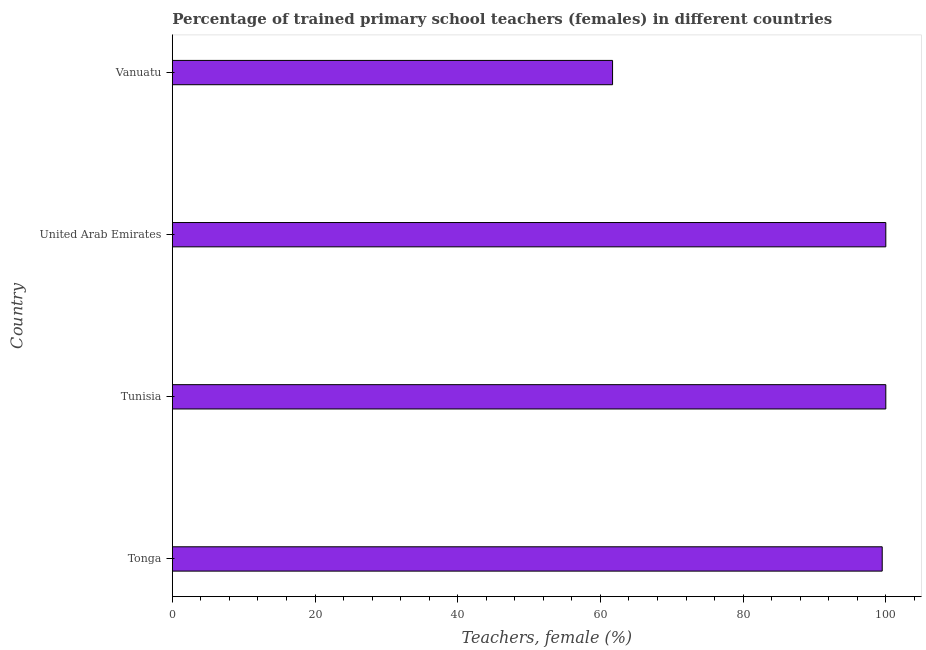Does the graph contain any zero values?
Keep it short and to the point. No. Does the graph contain grids?
Your answer should be very brief. No. What is the title of the graph?
Provide a short and direct response. Percentage of trained primary school teachers (females) in different countries. What is the label or title of the X-axis?
Offer a terse response. Teachers, female (%). What is the label or title of the Y-axis?
Your response must be concise. Country. Across all countries, what is the minimum percentage of trained female teachers?
Keep it short and to the point. 61.7. In which country was the percentage of trained female teachers maximum?
Give a very brief answer. Tunisia. In which country was the percentage of trained female teachers minimum?
Your answer should be compact. Vanuatu. What is the sum of the percentage of trained female teachers?
Ensure brevity in your answer.  361.19. What is the difference between the percentage of trained female teachers in Tonga and Vanuatu?
Provide a short and direct response. 37.8. What is the average percentage of trained female teachers per country?
Your answer should be compact. 90.3. What is the median percentage of trained female teachers?
Your answer should be very brief. 99.75. What is the ratio of the percentage of trained female teachers in Tunisia to that in Vanuatu?
Your response must be concise. 1.62. What is the difference between the highest and the second highest percentage of trained female teachers?
Your response must be concise. 0. Is the sum of the percentage of trained female teachers in Tunisia and United Arab Emirates greater than the maximum percentage of trained female teachers across all countries?
Provide a succinct answer. Yes. What is the difference between the highest and the lowest percentage of trained female teachers?
Make the answer very short. 38.3. What is the difference between two consecutive major ticks on the X-axis?
Ensure brevity in your answer.  20. Are the values on the major ticks of X-axis written in scientific E-notation?
Provide a short and direct response. No. What is the Teachers, female (%) in Tonga?
Keep it short and to the point. 99.49. What is the Teachers, female (%) in Tunisia?
Make the answer very short. 100. What is the Teachers, female (%) of United Arab Emirates?
Your answer should be very brief. 100. What is the Teachers, female (%) of Vanuatu?
Offer a very short reply. 61.7. What is the difference between the Teachers, female (%) in Tonga and Tunisia?
Your answer should be compact. -0.51. What is the difference between the Teachers, female (%) in Tonga and United Arab Emirates?
Give a very brief answer. -0.51. What is the difference between the Teachers, female (%) in Tonga and Vanuatu?
Offer a very short reply. 37.8. What is the difference between the Teachers, female (%) in Tunisia and Vanuatu?
Provide a short and direct response. 38.3. What is the difference between the Teachers, female (%) in United Arab Emirates and Vanuatu?
Give a very brief answer. 38.3. What is the ratio of the Teachers, female (%) in Tonga to that in United Arab Emirates?
Your answer should be very brief. 0.99. What is the ratio of the Teachers, female (%) in Tonga to that in Vanuatu?
Ensure brevity in your answer.  1.61. What is the ratio of the Teachers, female (%) in Tunisia to that in Vanuatu?
Make the answer very short. 1.62. What is the ratio of the Teachers, female (%) in United Arab Emirates to that in Vanuatu?
Keep it short and to the point. 1.62. 